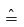Convert formula to latex. <formula><loc_0><loc_0><loc_500><loc_500>\hat { = }</formula> 